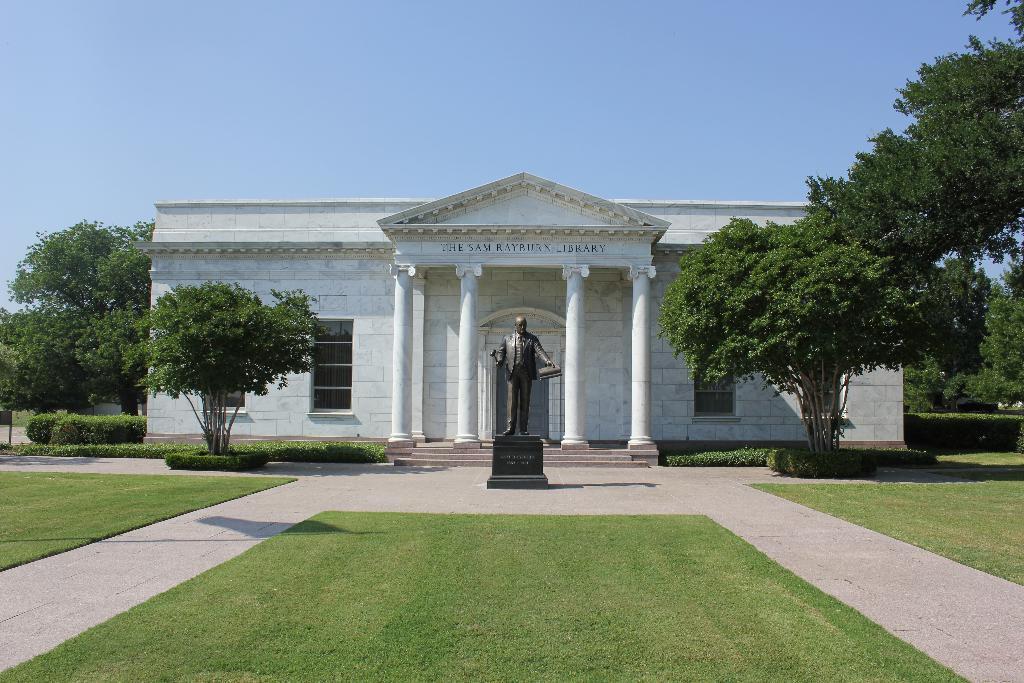Please provide a concise description of this image. In the image there is a clear sky and a white building made up of marble. In Front of the building there is a man statue, beside statue there are two trees and beside the building there are three trees in front of the trees there are plants infront of the plants there is a grass and beside the grass there is a footpath and in front of the statue there is a grass. 